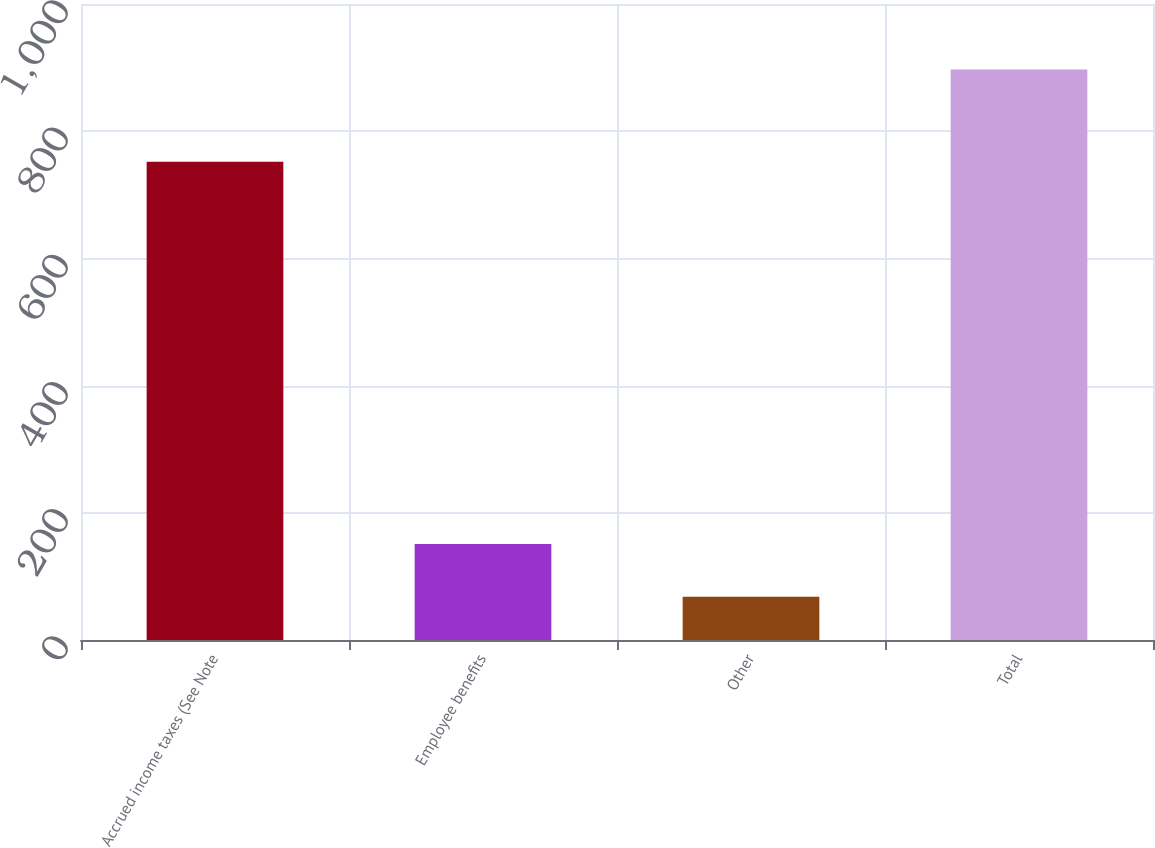Convert chart. <chart><loc_0><loc_0><loc_500><loc_500><bar_chart><fcel>Accrued income taxes (See Note<fcel>Employee benefits<fcel>Other<fcel>Total<nl><fcel>752<fcel>150.9<fcel>68<fcel>897<nl></chart> 